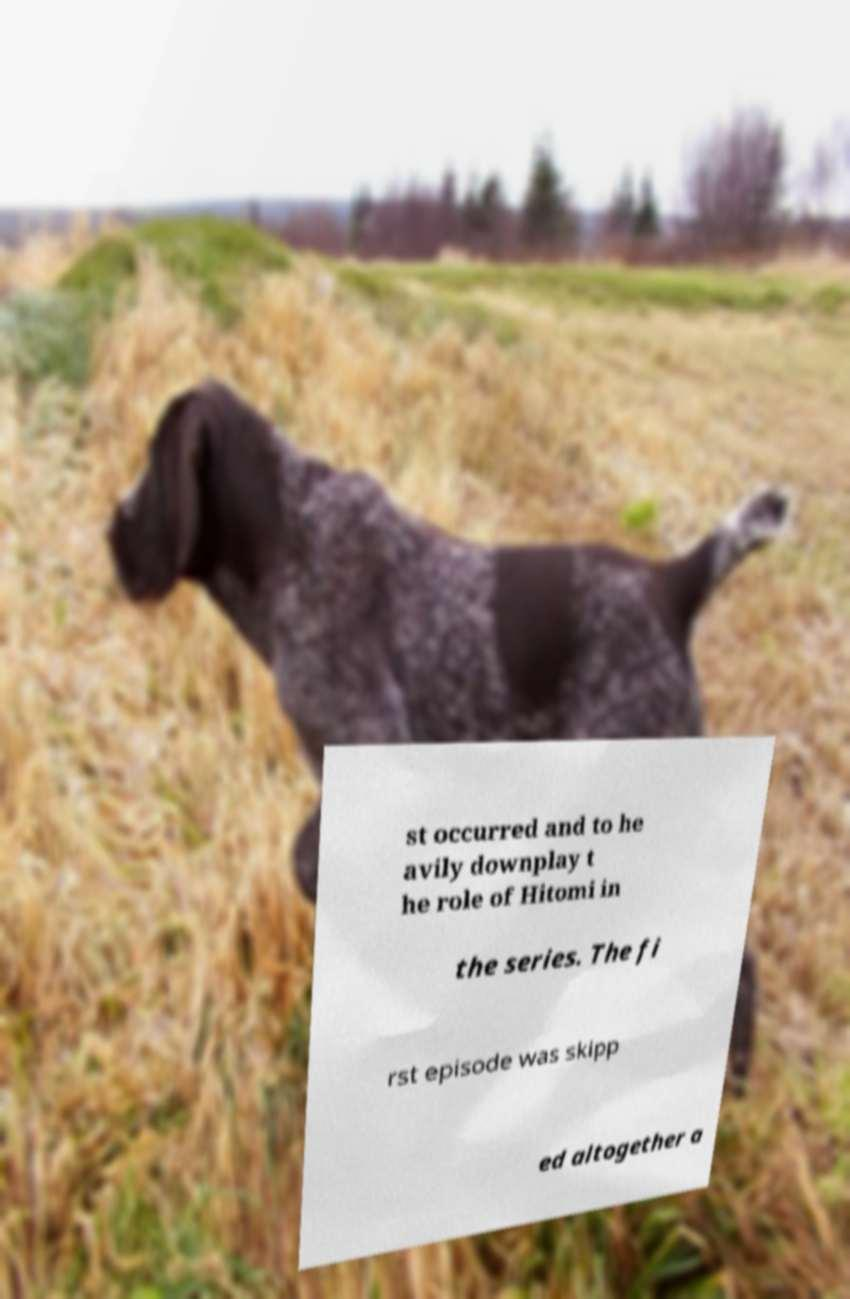Could you assist in decoding the text presented in this image and type it out clearly? st occurred and to he avily downplay t he role of Hitomi in the series. The fi rst episode was skipp ed altogether a 